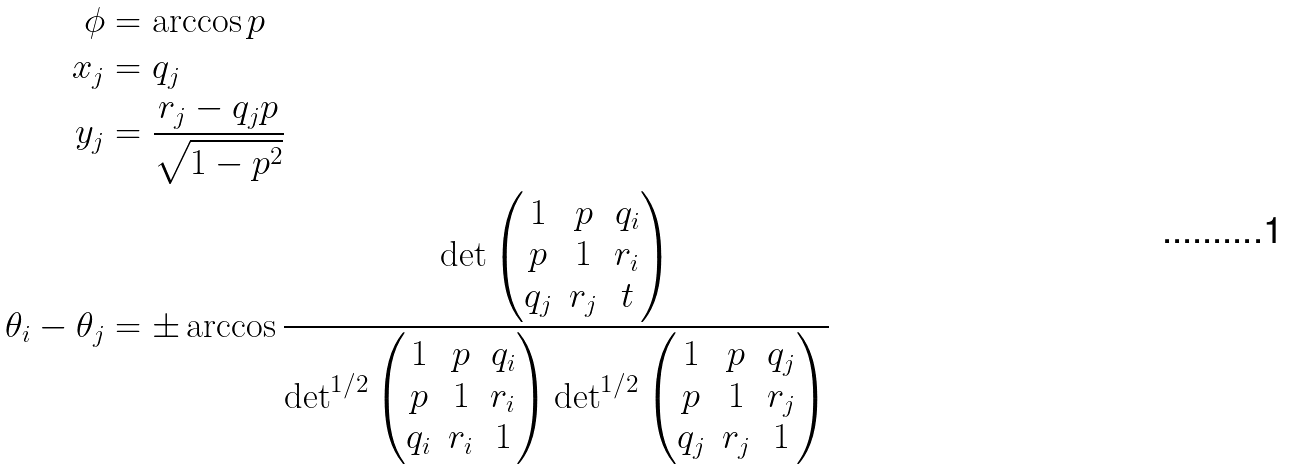<formula> <loc_0><loc_0><loc_500><loc_500>\phi & = \arccos p \\ x _ { j } & = q _ { j } \\ y _ { j } & = \frac { r _ { j } - q _ { j } p } { \sqrt { 1 - p ^ { 2 } } } \\ \theta _ { i } - \theta _ { j } & = \pm \arccos \frac { \det \begin{pmatrix} 1 & p & q _ { i } \\ p & 1 & r _ { i } \\ q _ { j } & r _ { j } & t \end{pmatrix} } { \det ^ { 1 / 2 } \begin{pmatrix} 1 & p & q _ { i } \\ p & 1 & r _ { i } \\ q _ { i } & r _ { i } & 1 \end{pmatrix} \det ^ { 1 / 2 } \begin{pmatrix} 1 & p & q _ { j } \\ p & 1 & r _ { j } \\ q _ { j } & r _ { j } & 1 \end{pmatrix} }</formula> 